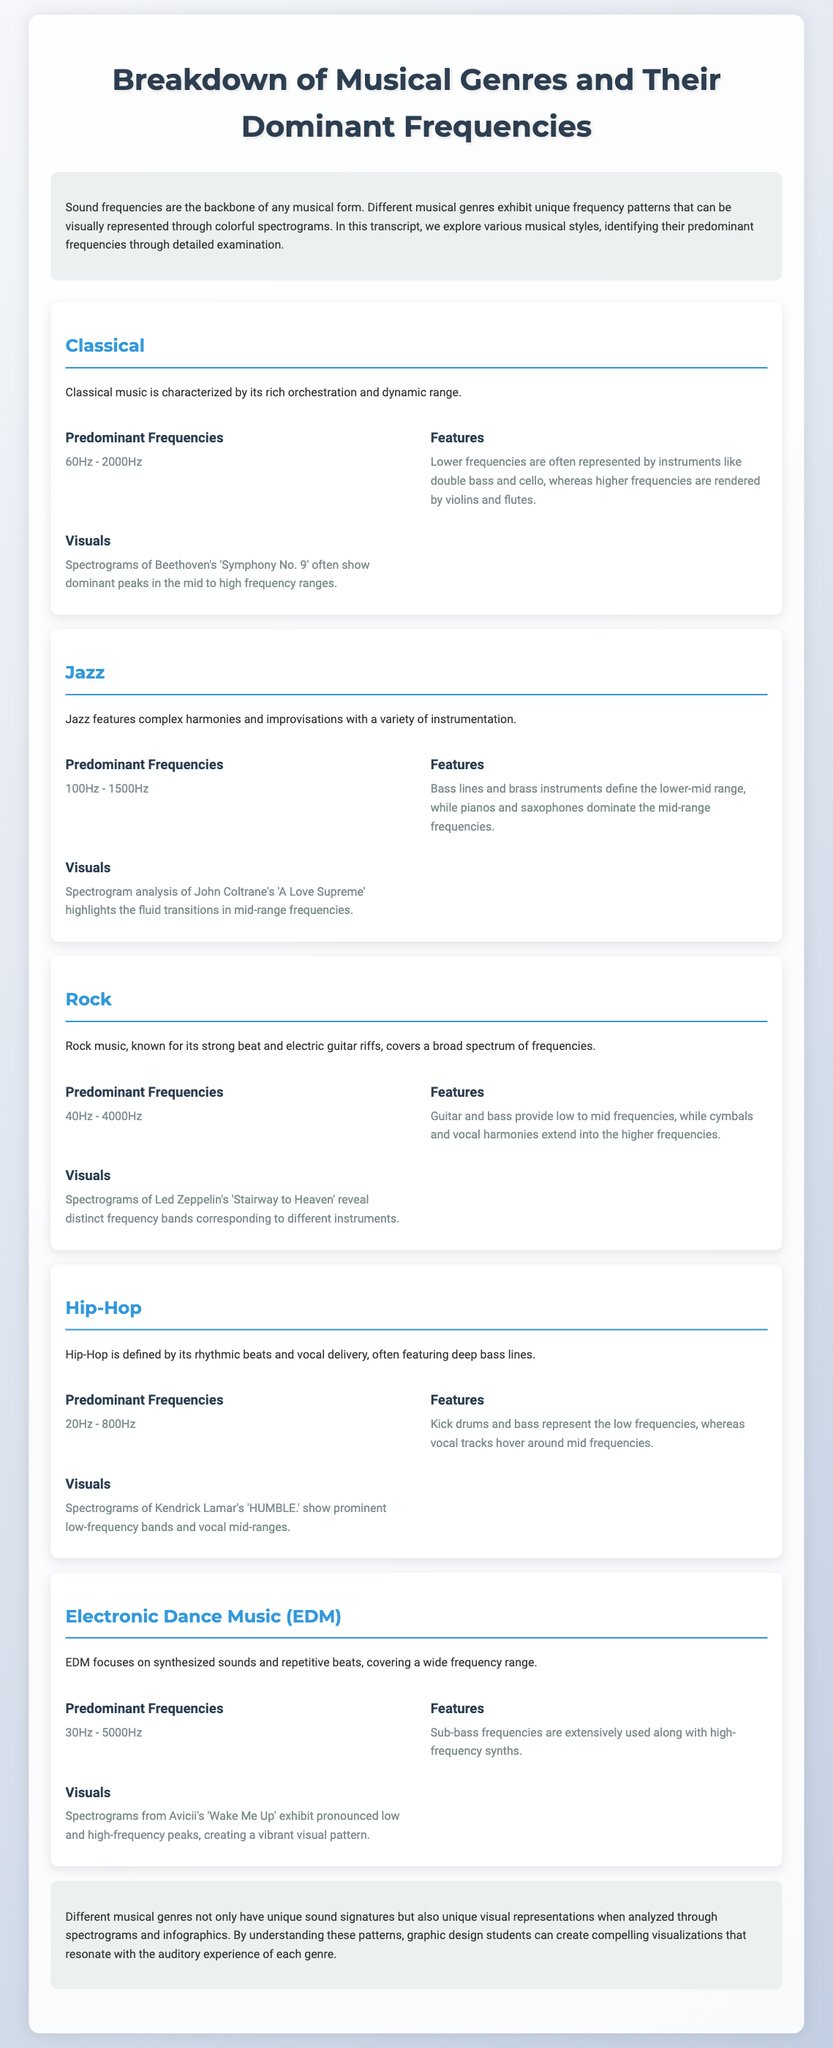What are the predominant frequencies of Classical music? The document states that Classical music has predominant frequencies between 60Hz and 2000Hz.
Answer: 60Hz - 2000Hz Which instrument features dominate in the lower frequencies of Jazz? According to the document, bass lines and brass instruments define the lower-mid range frequencies in Jazz.
Answer: Bass lines and brass instruments What is the frequency range for Hip-Hop music? The document indicates that the predominant frequencies for Hip-Hop music are between 20Hz and 800Hz.
Answer: 20Hz - 800Hz What distinctive element in Rock music covers the mid to high frequencies? The document notes that cymbals and vocal harmonies extend into the higher frequencies in Rock music.
Answer: Cymbals and vocal harmonies Which genre's spectrograms highlight fluid transitions in mid-range frequencies? The document mentions that spectrogram analysis of John Coltrane's 'A Love Supreme' highlights this feature in Jazz.
Answer: Jazz What unique visual representation can be created for different musical genres? The document explains that the unique visual representations are through spectrograms and infographics.
Answer: Spectrograms and infographics What is a defining characteristic of Electronic Dance Music's (EDM) sound? The document states that EDM focuses on synthesized sounds and repetitive beats.
Answer: Synthesized sounds and repetitive beats What peak frequency range is present in the spectrogram of Kendrick Lamar's 'HUMBLE.'? The document states that Kendrick Lamar's 'HUMBLE.' shows prominent low-frequency bands and vocal mid-ranges.
Answer: Low-frequency bands and vocal mid-ranges 